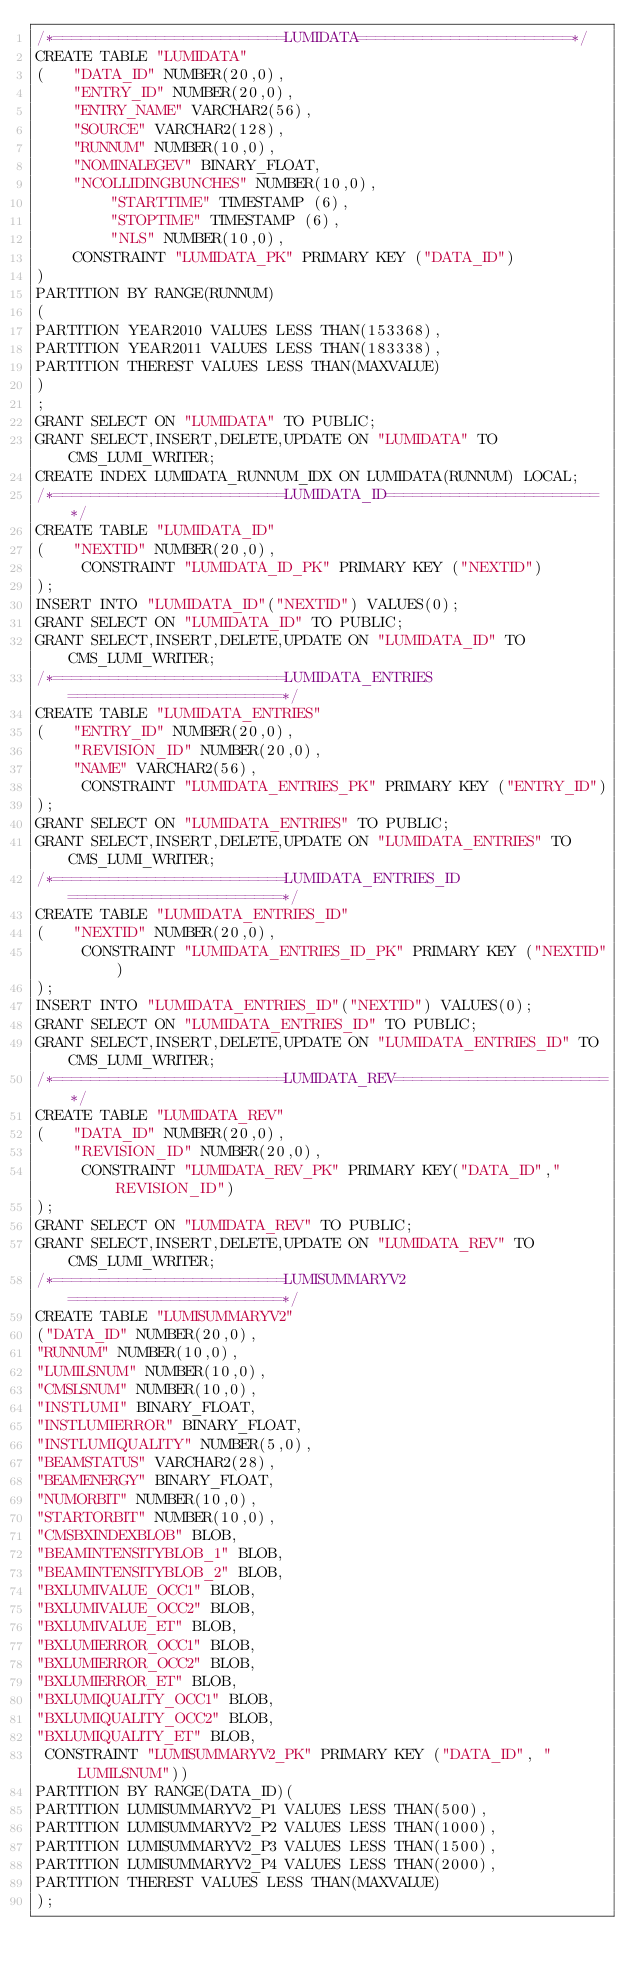<code> <loc_0><loc_0><loc_500><loc_500><_SQL_>/*=========================LUMIDATA=======================*/
CREATE TABLE "LUMIDATA"
(	"DATA_ID" NUMBER(20,0),
	"ENTRY_ID" NUMBER(20,0),
	"ENTRY_NAME" VARCHAR2(56),
	"SOURCE" VARCHAR2(128),
	"RUNNUM" NUMBER(10,0),
	"NOMINALEGEV" BINARY_FLOAT,
	"NCOLLIDINGBUNCHES" NUMBER(10,0),
     	"STARTTIME" TIMESTAMP (6), 
        "STOPTIME" TIMESTAMP (6),
        "NLS" NUMBER(10,0),
	CONSTRAINT "LUMIDATA_PK" PRIMARY KEY ("DATA_ID")
)
PARTITION BY RANGE(RUNNUM)
(
PARTITION YEAR2010 VALUES LESS THAN(153368),
PARTITION YEAR2011 VALUES LESS THAN(183338),
PARTITION THEREST VALUES LESS THAN(MAXVALUE)
)
;
GRANT SELECT ON "LUMIDATA" TO PUBLIC;
GRANT SELECT,INSERT,DELETE,UPDATE ON "LUMIDATA" TO CMS_LUMI_WRITER;
CREATE INDEX LUMIDATA_RUNNUM_IDX ON LUMIDATA(RUNNUM) LOCAL;
/*=========================LUMIDATA_ID=======================*/
CREATE TABLE "LUMIDATA_ID"
(	"NEXTID" NUMBER(20,0),
	 CONSTRAINT "LUMIDATA_ID_PK" PRIMARY KEY ("NEXTID")
);
INSERT INTO "LUMIDATA_ID"("NEXTID") VALUES(0);
GRANT SELECT ON "LUMIDATA_ID" TO PUBLIC;
GRANT SELECT,INSERT,DELETE,UPDATE ON "LUMIDATA_ID" TO CMS_LUMI_WRITER;
/*=========================LUMIDATA_ENTRIES=======================*/
CREATE TABLE "LUMIDATA_ENTRIES"
(	"ENTRY_ID" NUMBER(20,0),
	"REVISION_ID" NUMBER(20,0),
	"NAME" VARCHAR2(56),
	 CONSTRAINT "LUMIDATA_ENTRIES_PK" PRIMARY KEY ("ENTRY_ID")
);
GRANT SELECT ON "LUMIDATA_ENTRIES" TO PUBLIC;
GRANT SELECT,INSERT,DELETE,UPDATE ON "LUMIDATA_ENTRIES" TO CMS_LUMI_WRITER;
/*=========================LUMIDATA_ENTRIES_ID=======================*/
CREATE TABLE "LUMIDATA_ENTRIES_ID"
(	"NEXTID" NUMBER(20,0),
	 CONSTRAINT "LUMIDATA_ENTRIES_ID_PK" PRIMARY KEY ("NEXTID")
);
INSERT INTO "LUMIDATA_ENTRIES_ID"("NEXTID") VALUES(0);
GRANT SELECT ON "LUMIDATA_ENTRIES_ID" TO PUBLIC;
GRANT SELECT,INSERT,DELETE,UPDATE ON "LUMIDATA_ENTRIES_ID" TO CMS_LUMI_WRITER;
/*=========================LUMIDATA_REV=======================*/
CREATE TABLE "LUMIDATA_REV"
(	"DATA_ID" NUMBER(20,0),
	"REVISION_ID" NUMBER(20,0),
	 CONSTRAINT "LUMIDATA_REV_PK" PRIMARY KEY("DATA_ID","REVISION_ID")
);
GRANT SELECT ON "LUMIDATA_REV" TO PUBLIC;
GRANT SELECT,INSERT,DELETE,UPDATE ON "LUMIDATA_REV" TO CMS_LUMI_WRITER;
/*=========================LUMISUMMARYV2=======================*/
CREATE TABLE "LUMISUMMARYV2"
("DATA_ID" NUMBER(20,0),
"RUNNUM" NUMBER(10,0),
"LUMILSNUM" NUMBER(10,0),
"CMSLSNUM" NUMBER(10,0),
"INSTLUMI" BINARY_FLOAT,
"INSTLUMIERROR" BINARY_FLOAT,
"INSTLUMIQUALITY" NUMBER(5,0),
"BEAMSTATUS" VARCHAR2(28),
"BEAMENERGY" BINARY_FLOAT,
"NUMORBIT" NUMBER(10,0),
"STARTORBIT" NUMBER(10,0),
"CMSBXINDEXBLOB" BLOB,
"BEAMINTENSITYBLOB_1" BLOB,
"BEAMINTENSITYBLOB_2" BLOB,
"BXLUMIVALUE_OCC1" BLOB,
"BXLUMIVALUE_OCC2" BLOB,
"BXLUMIVALUE_ET" BLOB,
"BXLUMIERROR_OCC1" BLOB,
"BXLUMIERROR_OCC2" BLOB,
"BXLUMIERROR_ET" BLOB,
"BXLUMIQUALITY_OCC1" BLOB,
"BXLUMIQUALITY_OCC2" BLOB,
"BXLUMIQUALITY_ET" BLOB,
 CONSTRAINT "LUMISUMMARYV2_PK" PRIMARY KEY ("DATA_ID", "LUMILSNUM"))
PARTITION BY RANGE(DATA_ID)(
PARTITION LUMISUMMARYV2_P1 VALUES LESS THAN(500),
PARTITION LUMISUMMARYV2_P2 VALUES LESS THAN(1000),
PARTITION LUMISUMMARYV2_P3 VALUES LESS THAN(1500),
PARTITION LUMISUMMARYV2_P4 VALUES LESS THAN(2000),
PARTITION THEREST VALUES LESS THAN(MAXVALUE)
);</code> 